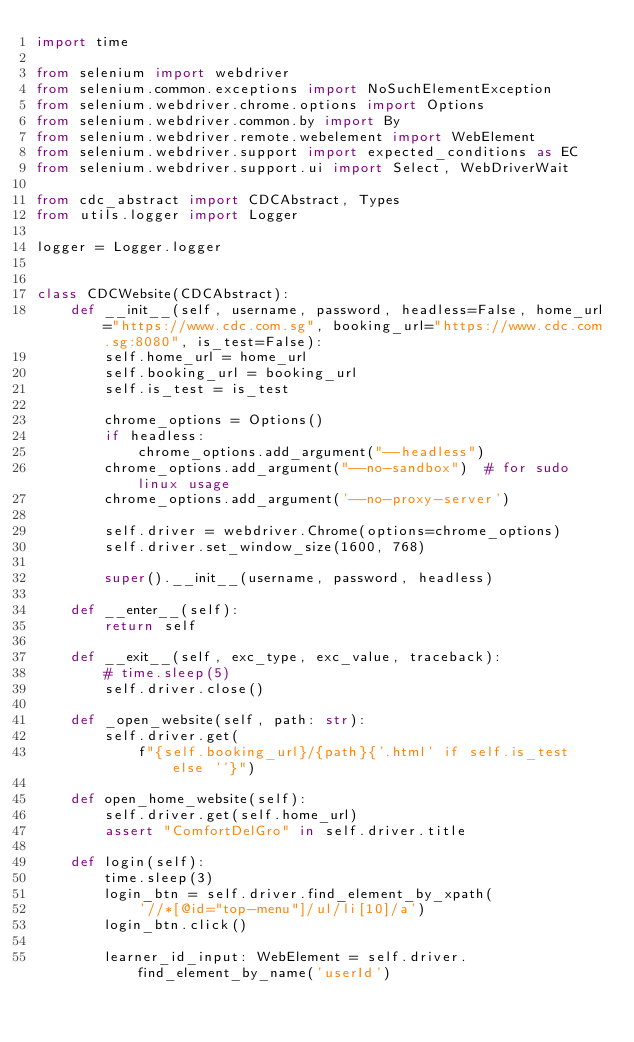Convert code to text. <code><loc_0><loc_0><loc_500><loc_500><_Python_>import time

from selenium import webdriver
from selenium.common.exceptions import NoSuchElementException
from selenium.webdriver.chrome.options import Options
from selenium.webdriver.common.by import By
from selenium.webdriver.remote.webelement import WebElement
from selenium.webdriver.support import expected_conditions as EC
from selenium.webdriver.support.ui import Select, WebDriverWait

from cdc_abstract import CDCAbstract, Types
from utils.logger import Logger

logger = Logger.logger


class CDCWebsite(CDCAbstract):
    def __init__(self, username, password, headless=False, home_url="https://www.cdc.com.sg", booking_url="https://www.cdc.com.sg:8080", is_test=False):
        self.home_url = home_url
        self.booking_url = booking_url
        self.is_test = is_test

        chrome_options = Options()
        if headless:
            chrome_options.add_argument("--headless")
        chrome_options.add_argument("--no-sandbox")  # for sudo linux usage
        chrome_options.add_argument('--no-proxy-server')

        self.driver = webdriver.Chrome(options=chrome_options)
        self.driver.set_window_size(1600, 768)

        super().__init__(username, password, headless)

    def __enter__(self):
        return self

    def __exit__(self, exc_type, exc_value, traceback):
        # time.sleep(5)
        self.driver.close()

    def _open_website(self, path: str):
        self.driver.get(
            f"{self.booking_url}/{path}{'.html' if self.is_test else ''}")

    def open_home_website(self):
        self.driver.get(self.home_url)
        assert "ComfortDelGro" in self.driver.title

    def login(self):
        time.sleep(3)
        login_btn = self.driver.find_element_by_xpath(
            '//*[@id="top-menu"]/ul/li[10]/a')
        login_btn.click()

        learner_id_input: WebElement = self.driver.find_element_by_name('userId')</code> 